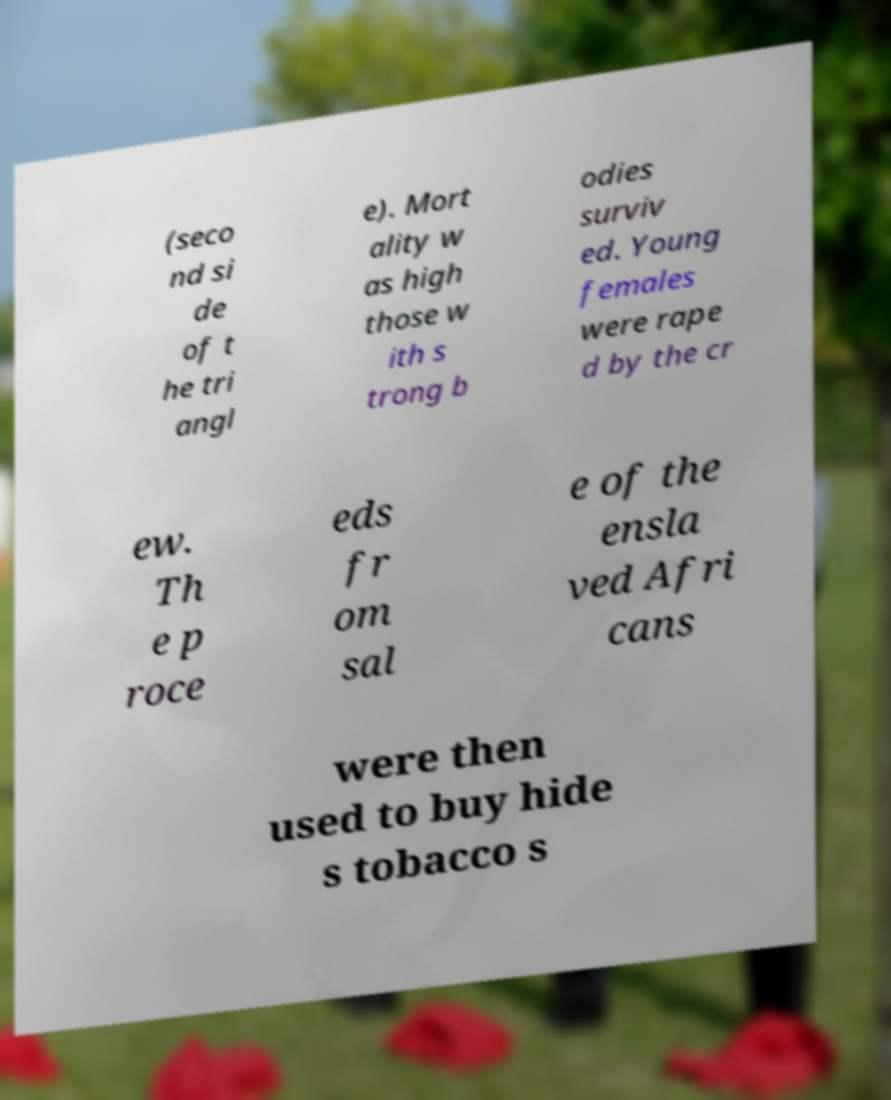There's text embedded in this image that I need extracted. Can you transcribe it verbatim? (seco nd si de of t he tri angl e). Mort ality w as high those w ith s trong b odies surviv ed. Young females were rape d by the cr ew. Th e p roce eds fr om sal e of the ensla ved Afri cans were then used to buy hide s tobacco s 